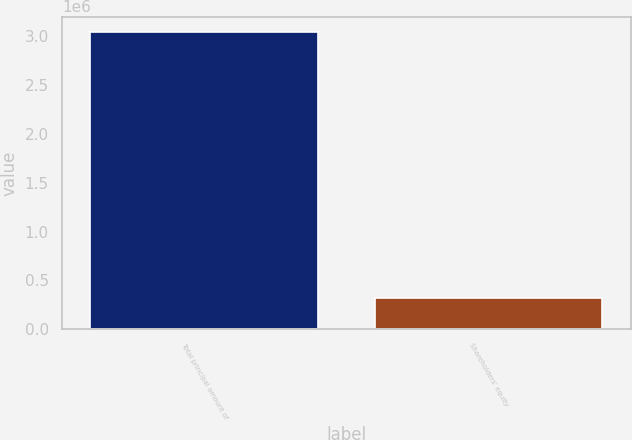Convert chart. <chart><loc_0><loc_0><loc_500><loc_500><bar_chart><fcel>Total principal amount of<fcel>Shareholders' equity<nl><fcel>3.05e+06<fcel>317110<nl></chart> 